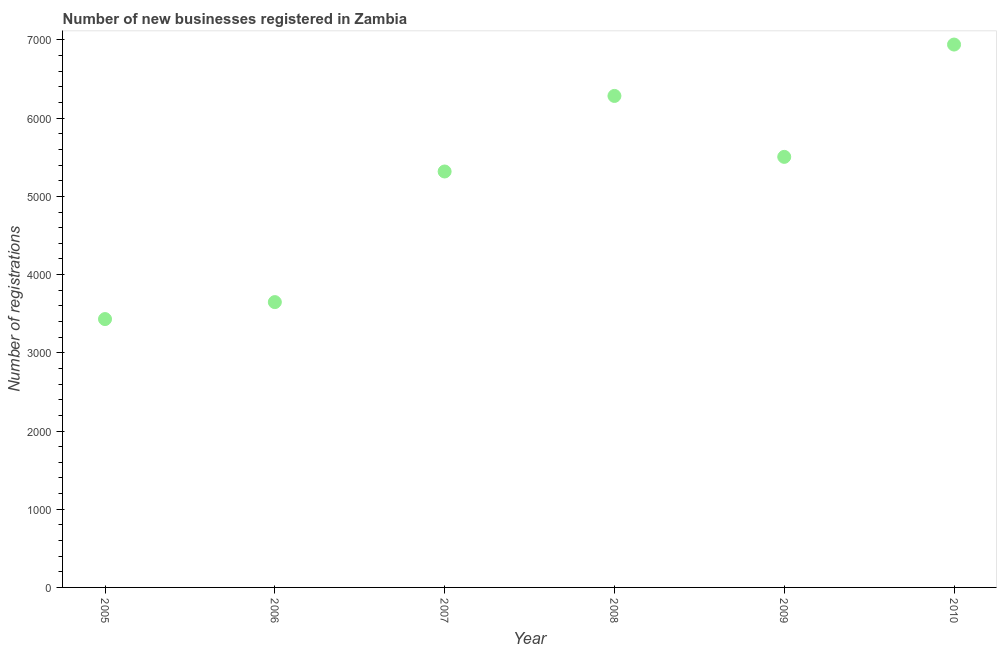What is the number of new business registrations in 2006?
Provide a succinct answer. 3648. Across all years, what is the maximum number of new business registrations?
Offer a terse response. 6941. Across all years, what is the minimum number of new business registrations?
Ensure brevity in your answer.  3431. In which year was the number of new business registrations maximum?
Make the answer very short. 2010. What is the sum of the number of new business registrations?
Give a very brief answer. 3.11e+04. What is the difference between the number of new business registrations in 2007 and 2009?
Ensure brevity in your answer.  -187. What is the average number of new business registrations per year?
Offer a terse response. 5187.83. What is the median number of new business registrations?
Provide a succinct answer. 5411.5. In how many years, is the number of new business registrations greater than 1000 ?
Give a very brief answer. 6. What is the ratio of the number of new business registrations in 2007 to that in 2008?
Your response must be concise. 0.85. Is the number of new business registrations in 2008 less than that in 2010?
Keep it short and to the point. Yes. Is the difference between the number of new business registrations in 2005 and 2007 greater than the difference between any two years?
Give a very brief answer. No. What is the difference between the highest and the second highest number of new business registrations?
Your response must be concise. 657. What is the difference between the highest and the lowest number of new business registrations?
Your response must be concise. 3510. Does the number of new business registrations monotonically increase over the years?
Your answer should be very brief. No. How many dotlines are there?
Your answer should be very brief. 1. How many years are there in the graph?
Your answer should be very brief. 6. What is the difference between two consecutive major ticks on the Y-axis?
Give a very brief answer. 1000. Are the values on the major ticks of Y-axis written in scientific E-notation?
Give a very brief answer. No. Does the graph contain any zero values?
Your answer should be compact. No. Does the graph contain grids?
Provide a short and direct response. No. What is the title of the graph?
Your answer should be very brief. Number of new businesses registered in Zambia. What is the label or title of the Y-axis?
Your answer should be very brief. Number of registrations. What is the Number of registrations in 2005?
Make the answer very short. 3431. What is the Number of registrations in 2006?
Ensure brevity in your answer.  3648. What is the Number of registrations in 2007?
Give a very brief answer. 5318. What is the Number of registrations in 2008?
Make the answer very short. 6284. What is the Number of registrations in 2009?
Make the answer very short. 5505. What is the Number of registrations in 2010?
Ensure brevity in your answer.  6941. What is the difference between the Number of registrations in 2005 and 2006?
Provide a short and direct response. -217. What is the difference between the Number of registrations in 2005 and 2007?
Give a very brief answer. -1887. What is the difference between the Number of registrations in 2005 and 2008?
Provide a succinct answer. -2853. What is the difference between the Number of registrations in 2005 and 2009?
Ensure brevity in your answer.  -2074. What is the difference between the Number of registrations in 2005 and 2010?
Make the answer very short. -3510. What is the difference between the Number of registrations in 2006 and 2007?
Your response must be concise. -1670. What is the difference between the Number of registrations in 2006 and 2008?
Offer a terse response. -2636. What is the difference between the Number of registrations in 2006 and 2009?
Your response must be concise. -1857. What is the difference between the Number of registrations in 2006 and 2010?
Your answer should be compact. -3293. What is the difference between the Number of registrations in 2007 and 2008?
Your response must be concise. -966. What is the difference between the Number of registrations in 2007 and 2009?
Provide a succinct answer. -187. What is the difference between the Number of registrations in 2007 and 2010?
Give a very brief answer. -1623. What is the difference between the Number of registrations in 2008 and 2009?
Provide a succinct answer. 779. What is the difference between the Number of registrations in 2008 and 2010?
Your answer should be compact. -657. What is the difference between the Number of registrations in 2009 and 2010?
Offer a very short reply. -1436. What is the ratio of the Number of registrations in 2005 to that in 2006?
Make the answer very short. 0.94. What is the ratio of the Number of registrations in 2005 to that in 2007?
Your answer should be compact. 0.65. What is the ratio of the Number of registrations in 2005 to that in 2008?
Offer a very short reply. 0.55. What is the ratio of the Number of registrations in 2005 to that in 2009?
Your response must be concise. 0.62. What is the ratio of the Number of registrations in 2005 to that in 2010?
Your answer should be compact. 0.49. What is the ratio of the Number of registrations in 2006 to that in 2007?
Your response must be concise. 0.69. What is the ratio of the Number of registrations in 2006 to that in 2008?
Offer a terse response. 0.58. What is the ratio of the Number of registrations in 2006 to that in 2009?
Your response must be concise. 0.66. What is the ratio of the Number of registrations in 2006 to that in 2010?
Keep it short and to the point. 0.53. What is the ratio of the Number of registrations in 2007 to that in 2008?
Your response must be concise. 0.85. What is the ratio of the Number of registrations in 2007 to that in 2009?
Offer a terse response. 0.97. What is the ratio of the Number of registrations in 2007 to that in 2010?
Offer a very short reply. 0.77. What is the ratio of the Number of registrations in 2008 to that in 2009?
Your answer should be compact. 1.14. What is the ratio of the Number of registrations in 2008 to that in 2010?
Give a very brief answer. 0.91. What is the ratio of the Number of registrations in 2009 to that in 2010?
Your answer should be compact. 0.79. 